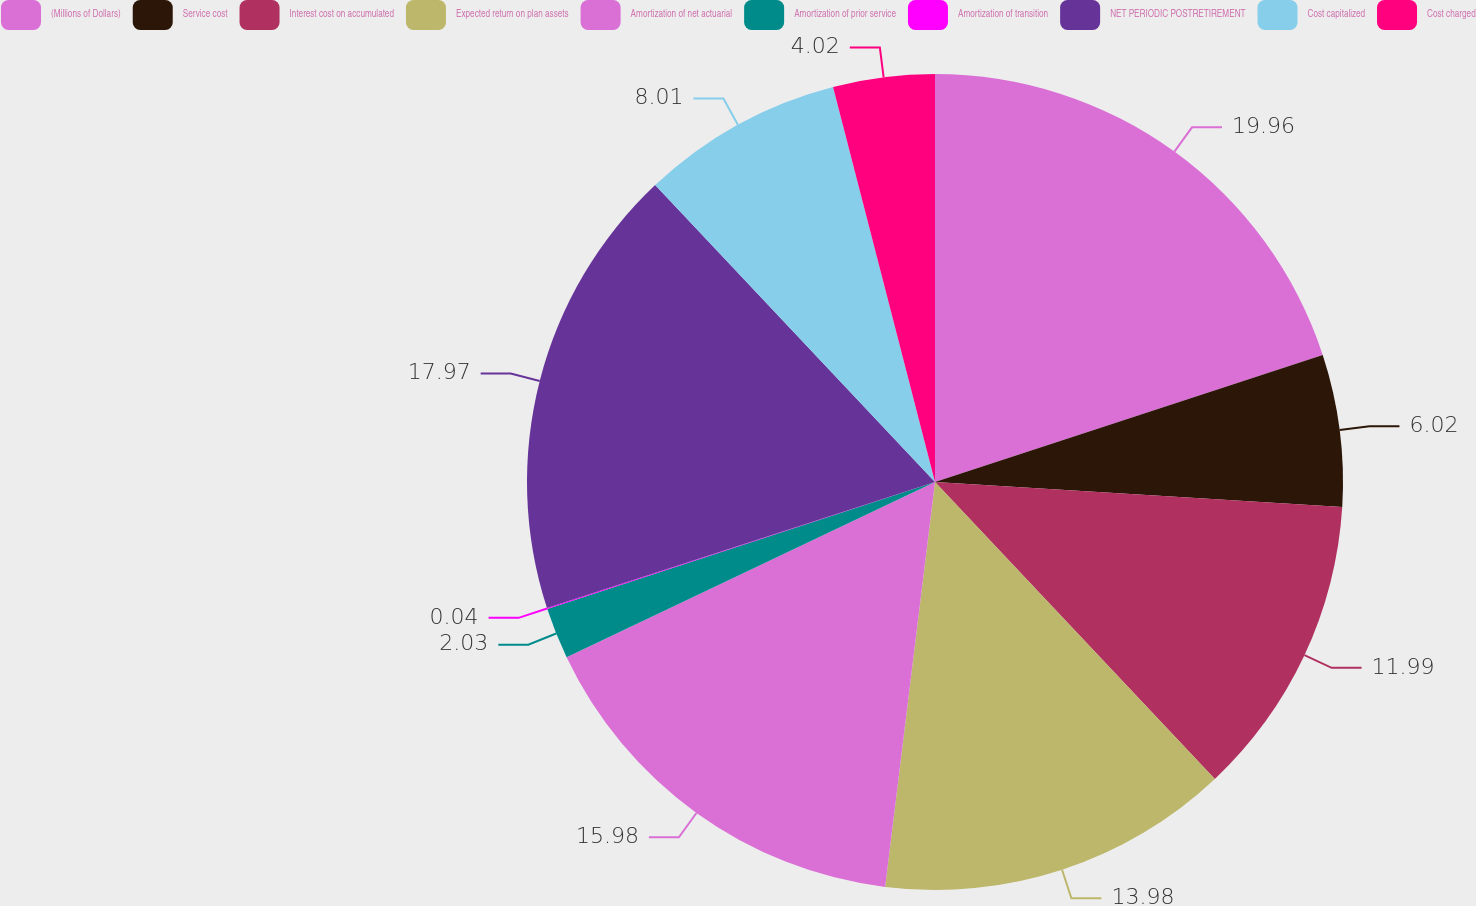Convert chart to OTSL. <chart><loc_0><loc_0><loc_500><loc_500><pie_chart><fcel>(Millions of Dollars)<fcel>Service cost<fcel>Interest cost on accumulated<fcel>Expected return on plan assets<fcel>Amortization of net actuarial<fcel>Amortization of prior service<fcel>Amortization of transition<fcel>NET PERIODIC POSTRETIREMENT<fcel>Cost capitalized<fcel>Cost charged<nl><fcel>19.96%<fcel>6.02%<fcel>11.99%<fcel>13.98%<fcel>15.98%<fcel>2.03%<fcel>0.04%<fcel>17.97%<fcel>8.01%<fcel>4.02%<nl></chart> 